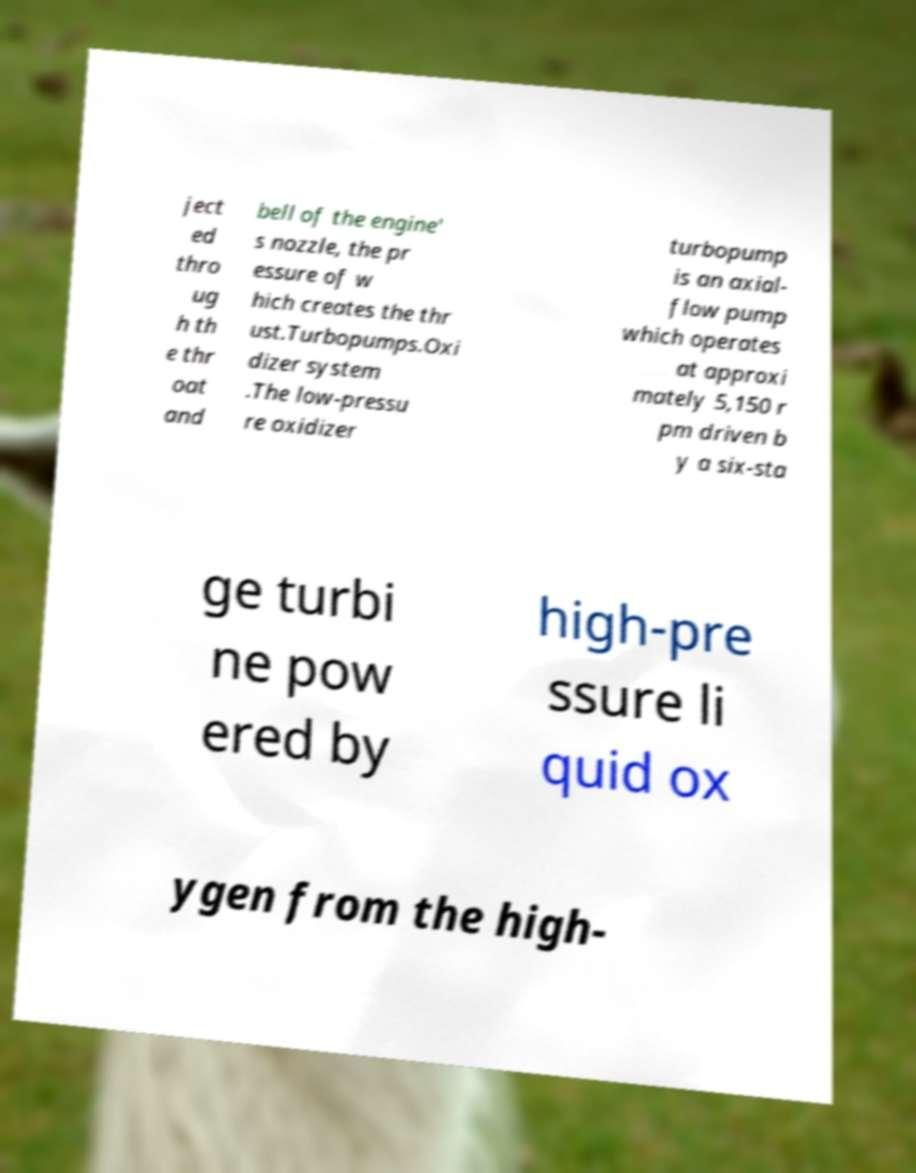Please read and relay the text visible in this image. What does it say? ject ed thro ug h th e thr oat and bell of the engine' s nozzle, the pr essure of w hich creates the thr ust.Turbopumps.Oxi dizer system .The low-pressu re oxidizer turbopump is an axial- flow pump which operates at approxi mately 5,150 r pm driven b y a six-sta ge turbi ne pow ered by high-pre ssure li quid ox ygen from the high- 